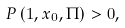<formula> <loc_0><loc_0><loc_500><loc_500>P \left ( 1 , x _ { 0 } , \Pi \right ) > 0 ,</formula> 